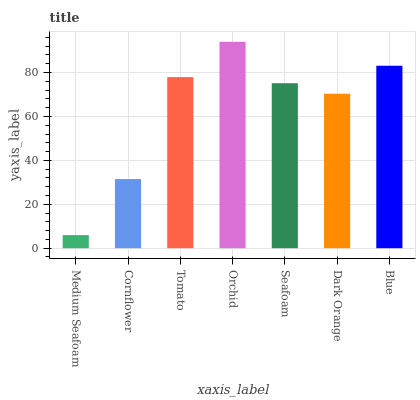Is Cornflower the minimum?
Answer yes or no. No. Is Cornflower the maximum?
Answer yes or no. No. Is Cornflower greater than Medium Seafoam?
Answer yes or no. Yes. Is Medium Seafoam less than Cornflower?
Answer yes or no. Yes. Is Medium Seafoam greater than Cornflower?
Answer yes or no. No. Is Cornflower less than Medium Seafoam?
Answer yes or no. No. Is Seafoam the high median?
Answer yes or no. Yes. Is Seafoam the low median?
Answer yes or no. Yes. Is Medium Seafoam the high median?
Answer yes or no. No. Is Medium Seafoam the low median?
Answer yes or no. No. 